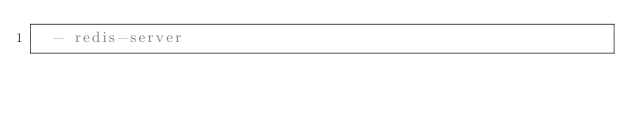<code> <loc_0><loc_0><loc_500><loc_500><_YAML_>  - redis-server

</code> 